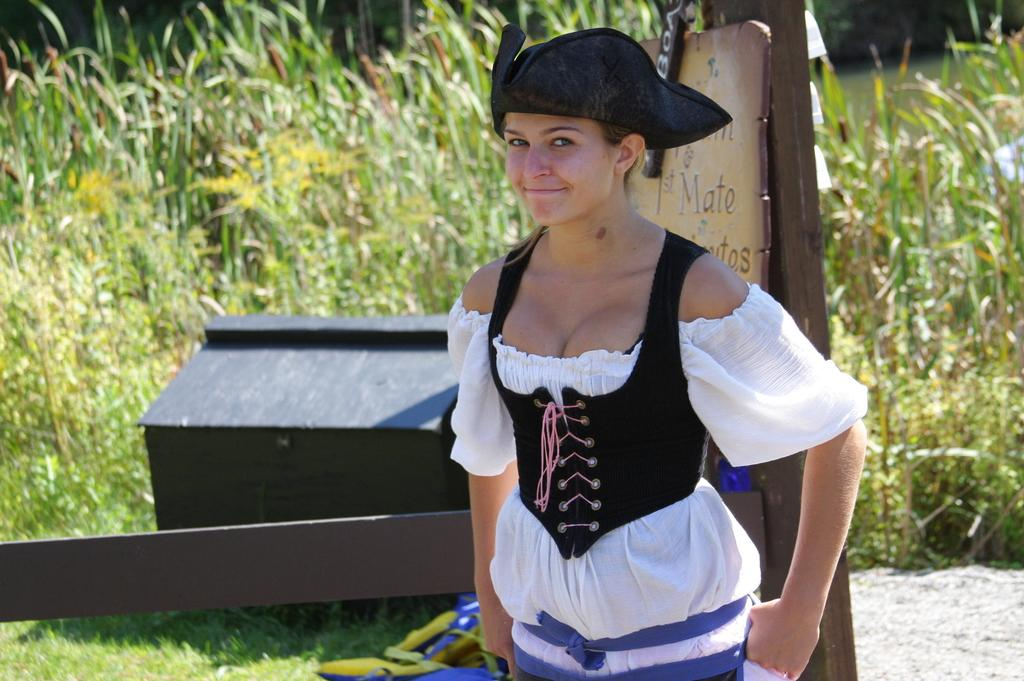<image>
Give a short and clear explanation of the subsequent image. a lady with the word mate behind her on the pole 